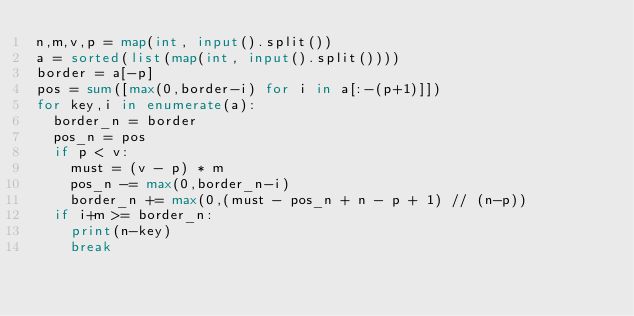<code> <loc_0><loc_0><loc_500><loc_500><_Python_>n,m,v,p = map(int, input().split())
a = sorted(list(map(int, input().split())))
border = a[-p]
pos = sum([max(0,border-i) for i in a[:-(p+1)]])
for key,i in enumerate(a):
  border_n = border
  pos_n = pos
  if p < v:
    must = (v - p) * m
    pos_n -= max(0,border_n-i)
    border_n += max(0,(must - pos_n + n - p + 1) // (n-p))
  if i+m >= border_n:
    print(n-key)
    break</code> 